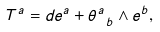<formula> <loc_0><loc_0><loc_500><loc_500>T ^ { a } = d e ^ { a } + \theta ^ { a } _ { \ b } \wedge e ^ { b } ,</formula> 